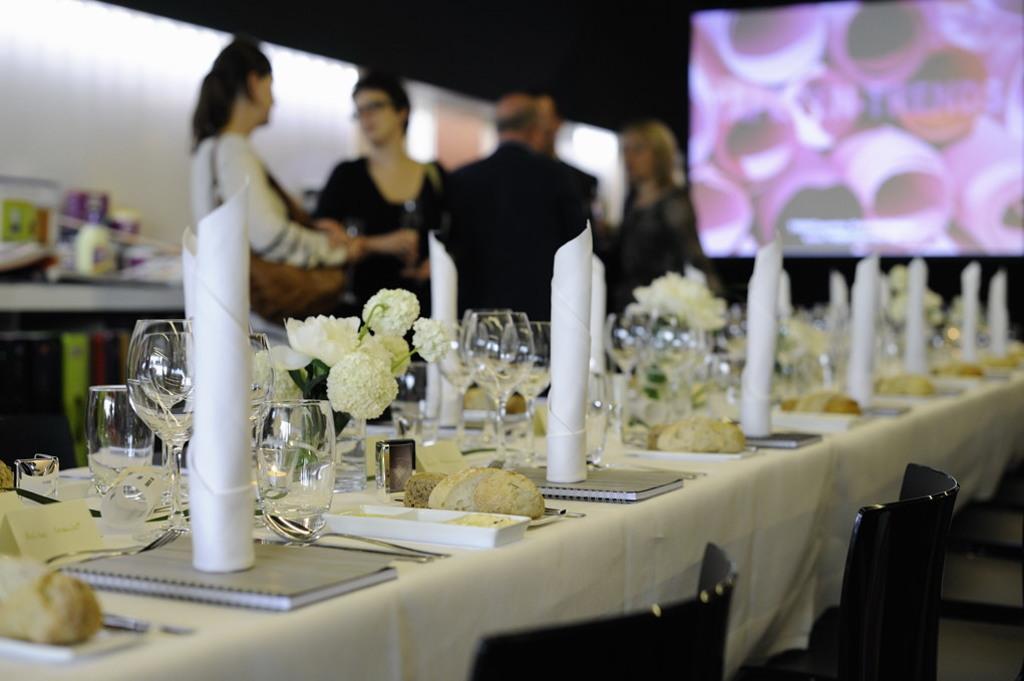Describe this image in one or two sentences. In the picture we can see a table, chairs. On the table we can find some glasses, tissues, flowers and table cloth. In the background we can find four people talking, and screen with some program in it. 